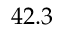Convert formula to latex. <formula><loc_0><loc_0><loc_500><loc_500>4 2 . 3</formula> 